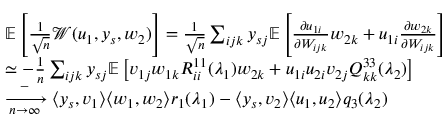<formula> <loc_0><loc_0><loc_500><loc_500>\begin{array} { r l } & { \mathbb { E } \left [ \frac { 1 } { \sqrt { n } } { \mathcal { W } } ( u _ { 1 } , y _ { s } , w _ { 2 } ) \right ] = \frac { 1 } { \sqrt { n } } \sum _ { i j k } y _ { s j } \mathbb { E } \left [ \frac { \partial u _ { 1 i } } { \partial W _ { i j k } } w _ { 2 k } + u _ { 1 i } \frac { \partial w _ { 2 k } } { \partial W _ { i j k } } \right ] } \\ & { \simeq - \frac { 1 } { n } \sum _ { i j k } y _ { s j } \mathbb { E } \left [ v _ { 1 j } w _ { 1 k } R _ { i i } ^ { 1 1 } ( \lambda _ { 1 } ) w _ { 2 k } + u _ { 1 i } u _ { 2 i } v _ { 2 j } Q _ { k k } ^ { 3 3 } ( \lambda _ { 2 } ) \right ] } \\ & { \xrightarrow [ n \to \infty ] - \langle y _ { s } , v _ { 1 } \rangle \langle w _ { 1 } , w _ { 2 } \rangle r _ { 1 } ( \lambda _ { 1 } ) - \langle y _ { s } , v _ { 2 } \rangle \langle u _ { 1 } , u _ { 2 } \rangle q _ { 3 } ( \lambda _ { 2 } ) } \end{array}</formula> 